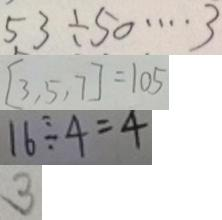<formula> <loc_0><loc_0><loc_500><loc_500>5 3 \div 5 0 \cdots 3 
 [ 3 , 5 , 7 ] = 1 0 5 
 1 6 \div 4 = 4 
 3</formula> 